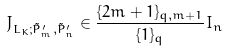Convert formula to latex. <formula><loc_0><loc_0><loc_500><loc_500>J _ { L _ { K } ; \tilde { P } _ { m } ^ { \prime } , \tilde { P } _ { n } ^ { \prime } } \in \frac { \{ 2 m + 1 \} _ { q , m + 1 } } { \{ 1 \} _ { q } } I _ { n }</formula> 